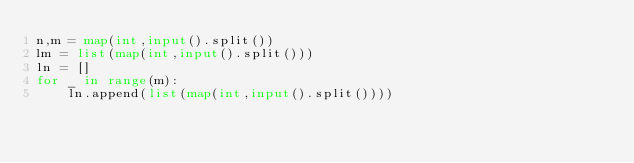<code> <loc_0><loc_0><loc_500><loc_500><_Python_>n,m = map(int,input().split())
lm = list(map(int,input().split()))
ln = []
for _ in range(m):
    ln.append(list(map(int,input().split())))</code> 